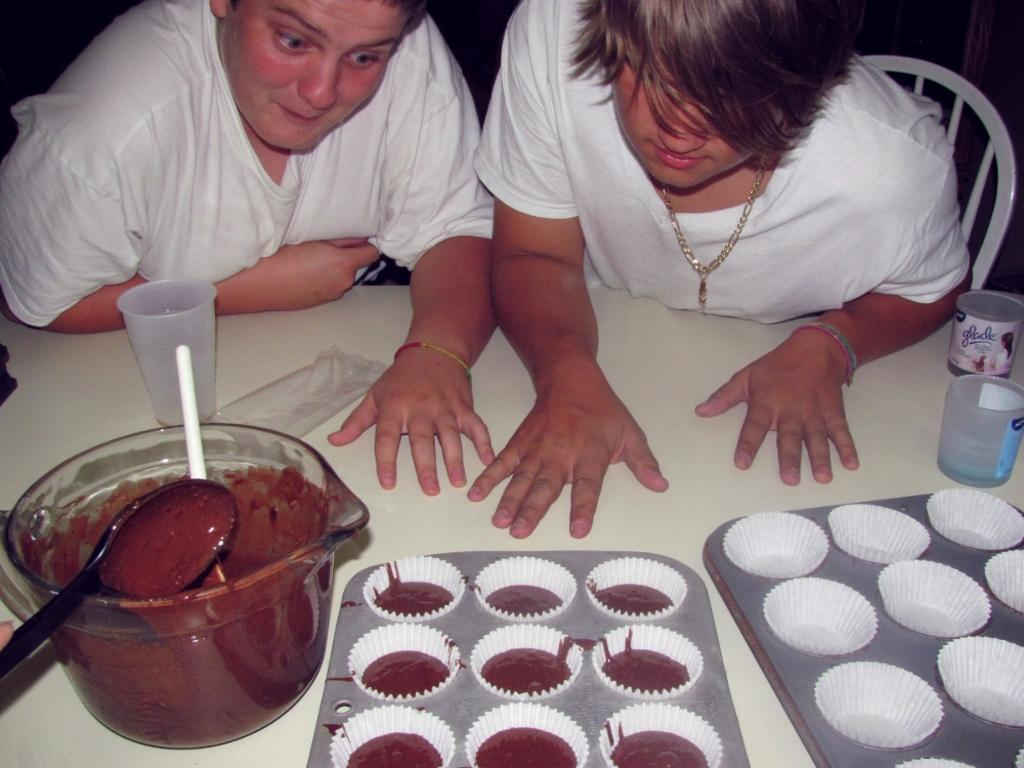How many people are sitting in the image? There are two people sitting on chairs in the image. What is on the table in the image? There are trays, a bowl, spoons, and additional objects on the table. What might the people be using the spoons for? The spoons might be used for eating or serving food from the bowl or trays on the table. Can you describe the additional objects on the table? Unfortunately, the provided facts do not specify the nature of the additional objects on the table. What type of metal is used to construct the toy in the image? There is no toy present in the image, so it is not possible to determine the type of metal used in its construction. 